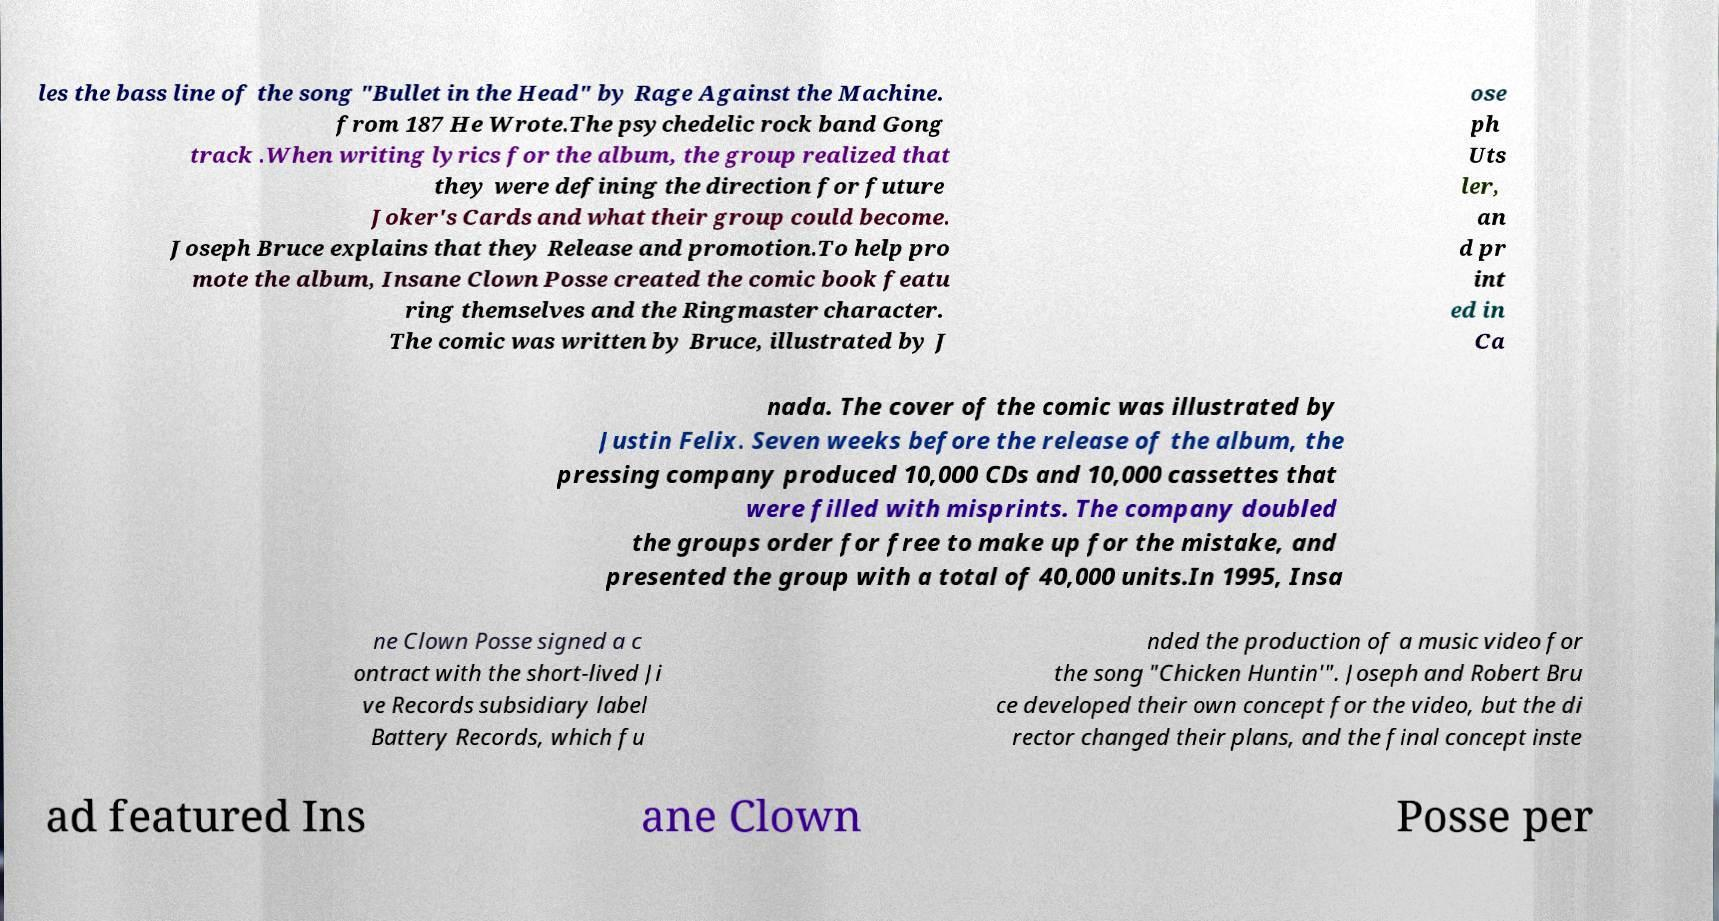Please identify and transcribe the text found in this image. les the bass line of the song "Bullet in the Head" by Rage Against the Machine. from 187 He Wrote.The psychedelic rock band Gong track .When writing lyrics for the album, the group realized that they were defining the direction for future Joker's Cards and what their group could become. Joseph Bruce explains that they Release and promotion.To help pro mote the album, Insane Clown Posse created the comic book featu ring themselves and the Ringmaster character. The comic was written by Bruce, illustrated by J ose ph Uts ler, an d pr int ed in Ca nada. The cover of the comic was illustrated by Justin Felix. Seven weeks before the release of the album, the pressing company produced 10,000 CDs and 10,000 cassettes that were filled with misprints. The company doubled the groups order for free to make up for the mistake, and presented the group with a total of 40,000 units.In 1995, Insa ne Clown Posse signed a c ontract with the short-lived Ji ve Records subsidiary label Battery Records, which fu nded the production of a music video for the song "Chicken Huntin'". Joseph and Robert Bru ce developed their own concept for the video, but the di rector changed their plans, and the final concept inste ad featured Ins ane Clown Posse per 